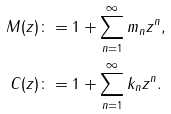Convert formula to latex. <formula><loc_0><loc_0><loc_500><loc_500>M ( z ) & \colon = 1 + \sum _ { n = 1 } ^ { \infty } m _ { n } z ^ { n } , \\ C ( z ) & \colon = 1 + \sum _ { n = 1 } ^ { \infty } k _ { n } z ^ { n } .</formula> 